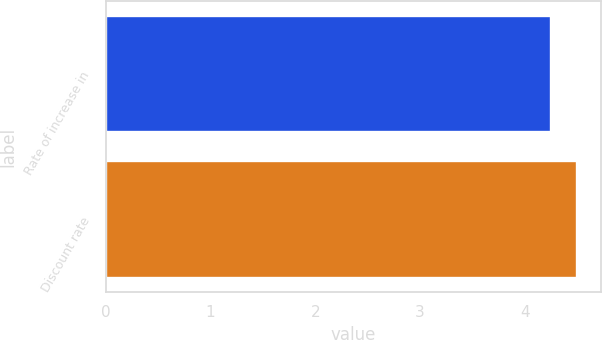Convert chart to OTSL. <chart><loc_0><loc_0><loc_500><loc_500><bar_chart><fcel>Rate of increase in<fcel>Discount rate<nl><fcel>4.25<fcel>4.5<nl></chart> 